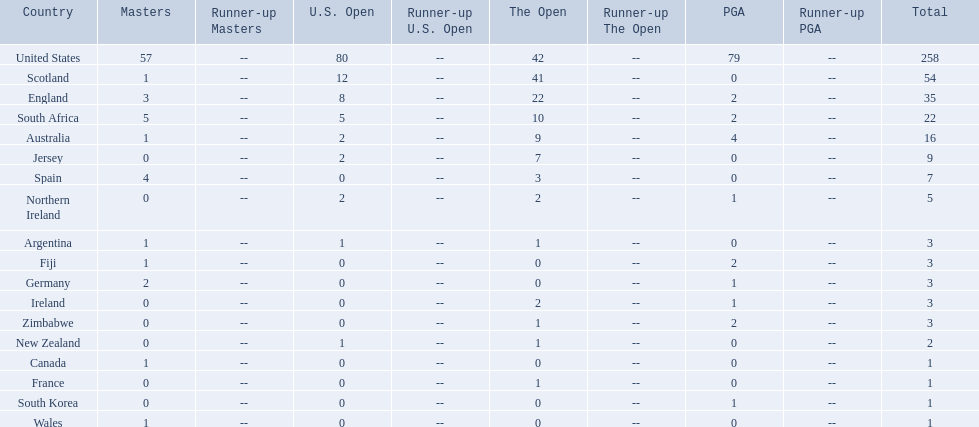What are all the countries? United States, Scotland, England, South Africa, Australia, Jersey, Spain, Northern Ireland, Argentina, Fiji, Germany, Ireland, Zimbabwe, New Zealand, Canada, France, South Korea, Wales. Which ones are located in africa? South Africa, Zimbabwe. Of those, which has the least champion golfers? Zimbabwe. 